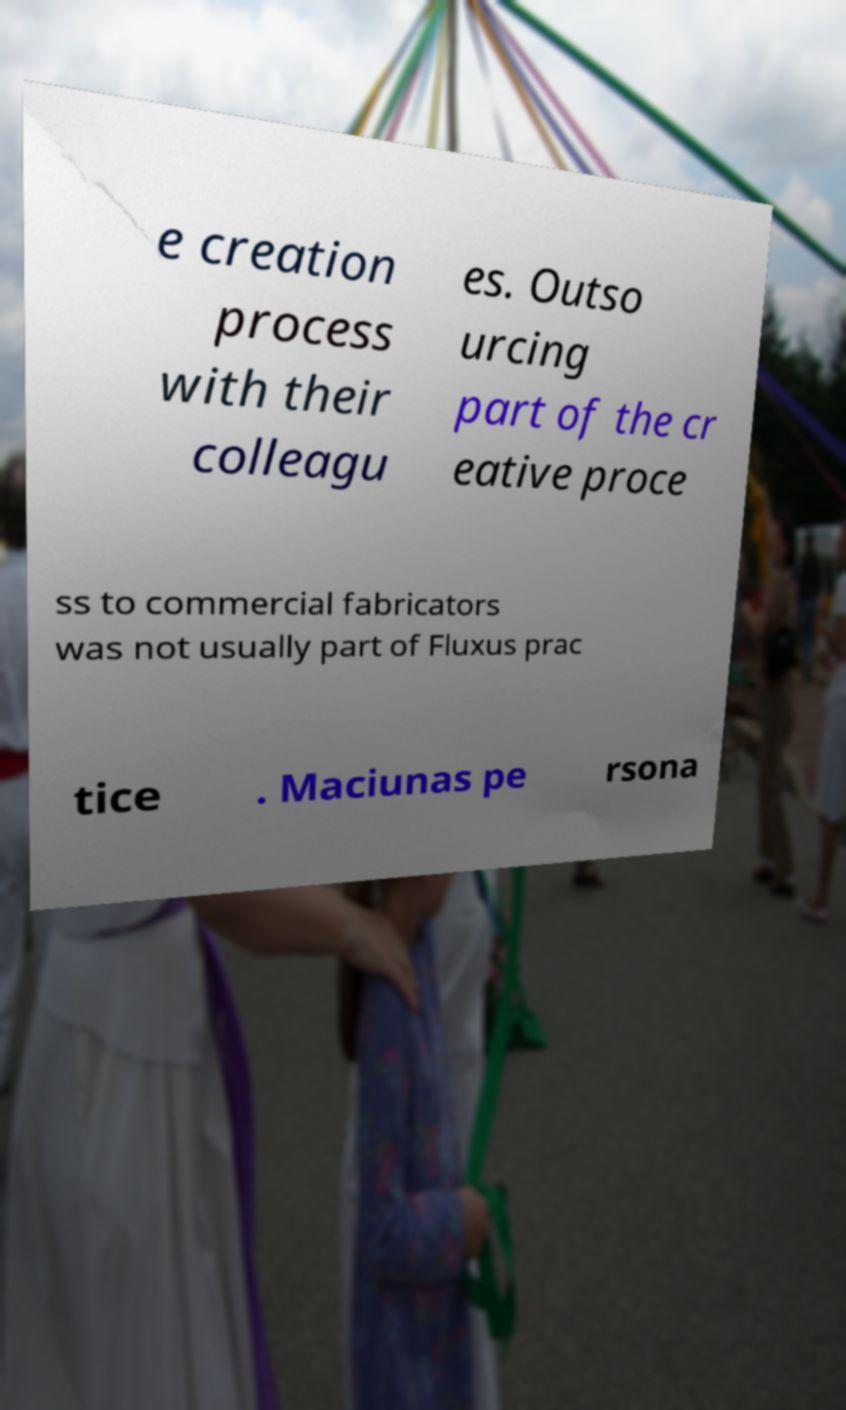Could you extract and type out the text from this image? e creation process with their colleagu es. Outso urcing part of the cr eative proce ss to commercial fabricators was not usually part of Fluxus prac tice . Maciunas pe rsona 